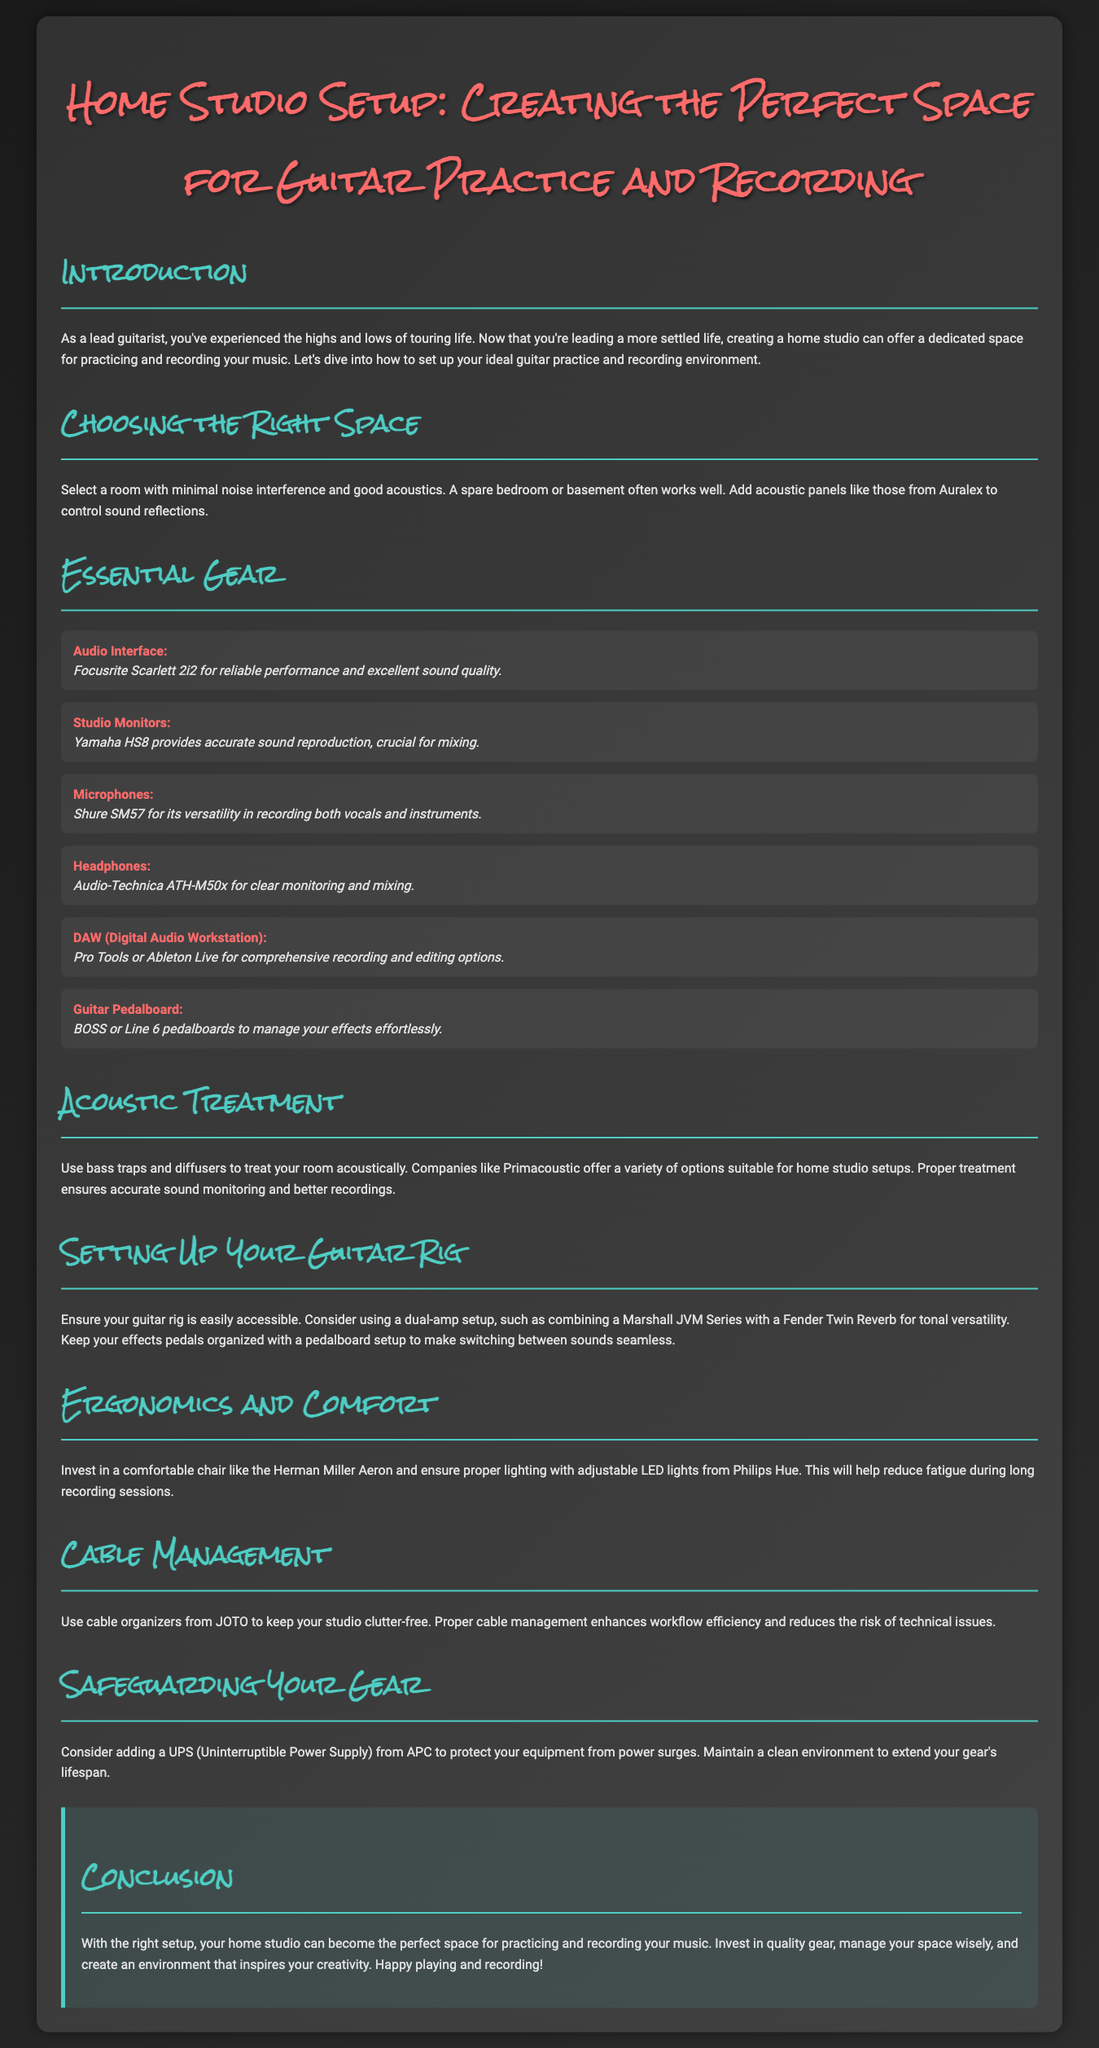What is the primary purpose of the document? The document aims to help guitarists create an ideal home studio setup for practice and recording.
Answer: Creating a home studio setup What is a recommended audio interface listed in the document? The document specifically mentions the Focusrite Scarlett 2i2 as a reliable audio interface.
Answer: Focusrite Scarlett 2i2 What type of microphones does the document recommend? It recommends the Shure SM57 for recording both vocals and instruments.
Answer: Shure SM57 Which studio monitors are highlighted for accurate sound reproduction? The document highlights Yamaha HS8 as the studio monitors that provide accurate sound reproduction.
Answer: Yamaha HS8 What specific ergonomic chair is suggested for comfort during long sessions? The document suggests investing in the Herman Miller Aeron for comfort during long recording sessions.
Answer: Herman Miller Aeron How does the document suggest maintaining a clutter-free studio? It recommends using cable organizers from JOTO to keep the studio cable management.
Answer: JOTO What treatment does the document recommend for acoustics? The document recommends using bass traps and diffusers to improve room acoustics.
Answer: Bass traps and diffusers What is the suggested dual-amp setup for tonal versatility? The document suggests combining a Marshall JVM Series with a Fender Twin Reverb for a dual-amp setup.
Answer: Marshall JVM Series and Fender Twin Reverb What is the function of adding a UPS to the studio? A UPS is recommended to protect the equipment from power surges, enhancing gear safety.
Answer: Protects from power surges 